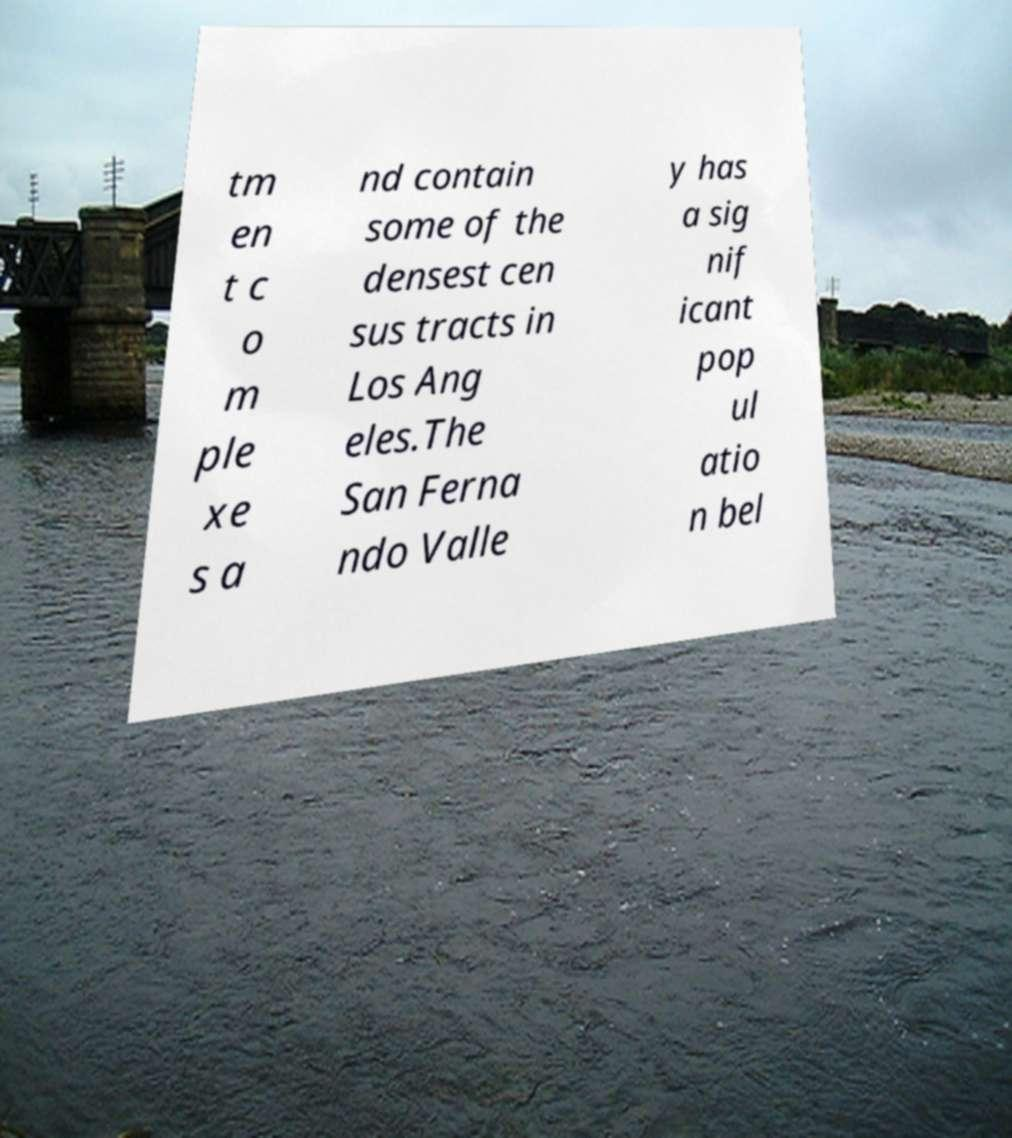Could you assist in decoding the text presented in this image and type it out clearly? tm en t c o m ple xe s a nd contain some of the densest cen sus tracts in Los Ang eles.The San Ferna ndo Valle y has a sig nif icant pop ul atio n bel 